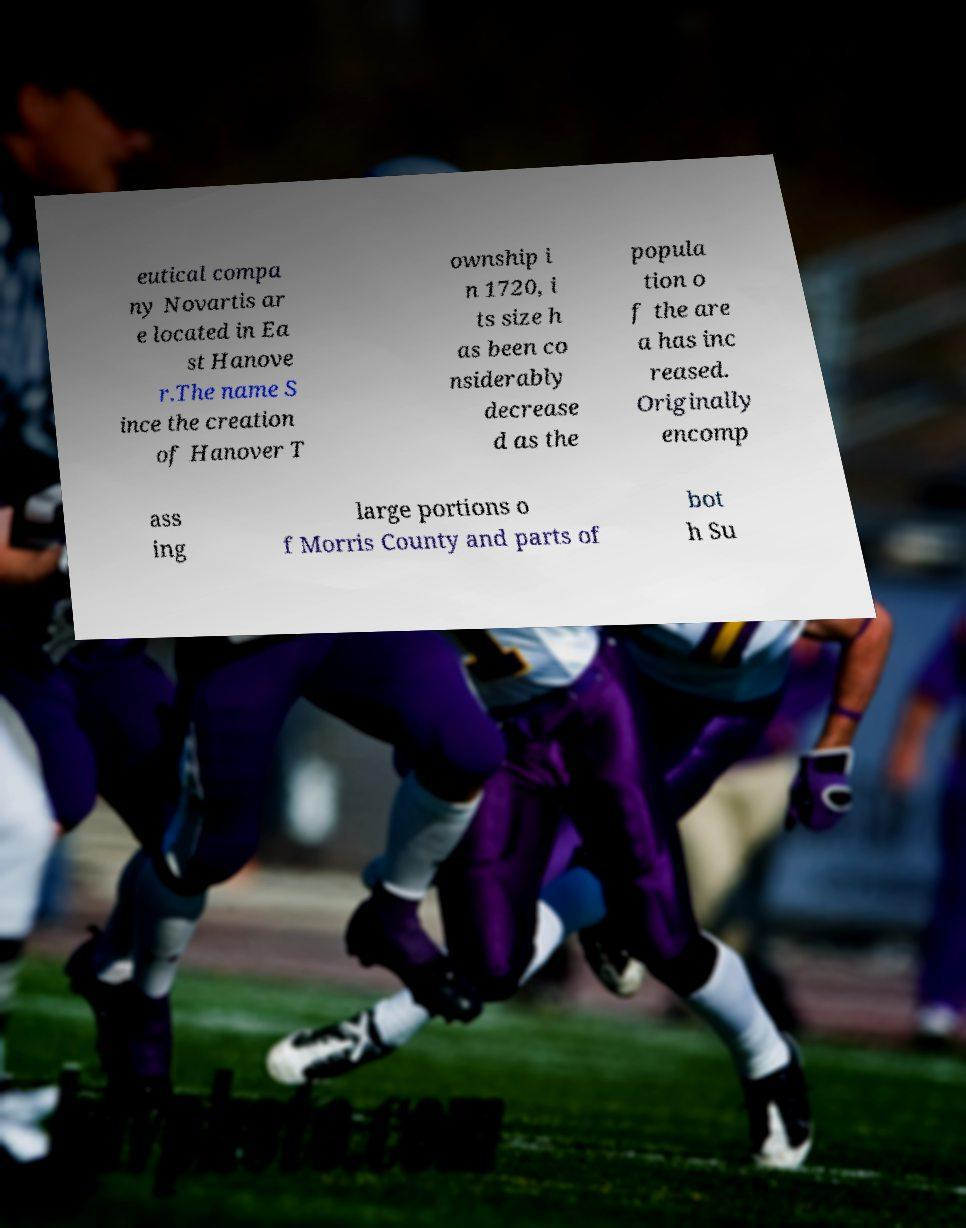For documentation purposes, I need the text within this image transcribed. Could you provide that? eutical compa ny Novartis ar e located in Ea st Hanove r.The name S ince the creation of Hanover T ownship i n 1720, i ts size h as been co nsiderably decrease d as the popula tion o f the are a has inc reased. Originally encomp ass ing large portions o f Morris County and parts of bot h Su 